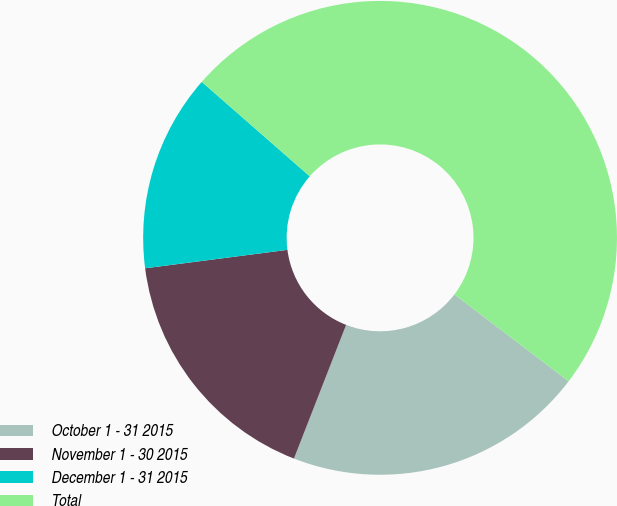Convert chart to OTSL. <chart><loc_0><loc_0><loc_500><loc_500><pie_chart><fcel>October 1 - 31 2015<fcel>November 1 - 30 2015<fcel>December 1 - 31 2015<fcel>Total<nl><fcel>20.57%<fcel>17.03%<fcel>13.49%<fcel>48.91%<nl></chart> 